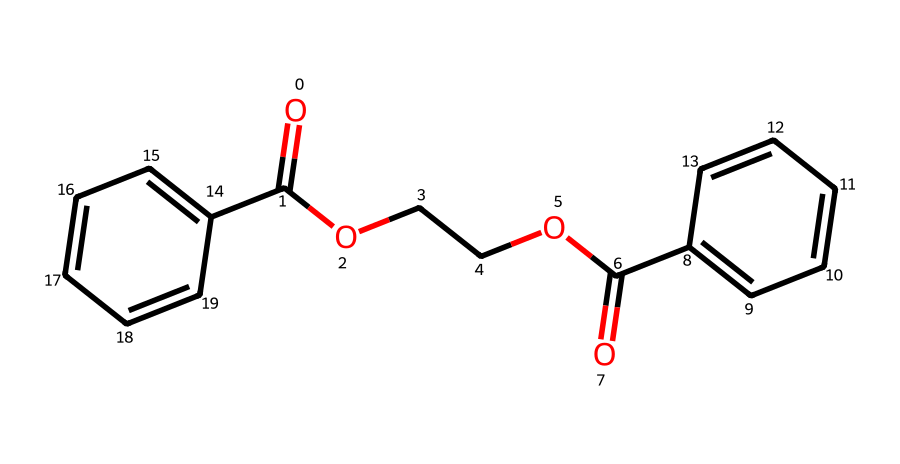How many carbon atoms are in this structure? The structure contains multiple rings and carbonyl groups which can be counted systematically. By analyzing the SMILES representation, we identify carbon atoms in the aromatic rings and those attached to functional groups. There are a total of 18 carbon atoms in the structure.
Answer: 18 What type of functional groups are present in this chemical? Looking at the structure derived from the SMILES, we see both ester (-COO-) groups from the ethylene glycol and carboxylic acid groups (-COOH) from the terephthalic acid. These functional groups are characteristic of polyesters like PET.
Answer: ester, carboxylic acid What is the primary use of polyethylene terephthalate? Polyethylene terephthalate, given its properties of durability and clarity, is predominantly used in the manufacture of plastic bottles for beverages and other liquids.
Answer: plastic bottles How many oxygen atoms are in the structure? The careful identification of oxygen atoms in the SMILES shows they are present in the ester linkages and carboxylic acid groups. Counting them yields a total of 4 oxygen atoms.
Answer: 4 What does the presence of aromatic rings indicate about this compound? The presence of aromatic rings in the structure signifies stability and rigidity; this is a common feature in thermoplastic polymers that influences physical properties, including resistance to heat and impact.
Answer: stability, rigidity What is the molecular formula for this compound? By analyzing the SMILES representation and counting the various atoms, we can deduce the molecular formula as C10H8O4, representing the constituents of the structure.
Answer: C10H8O4 